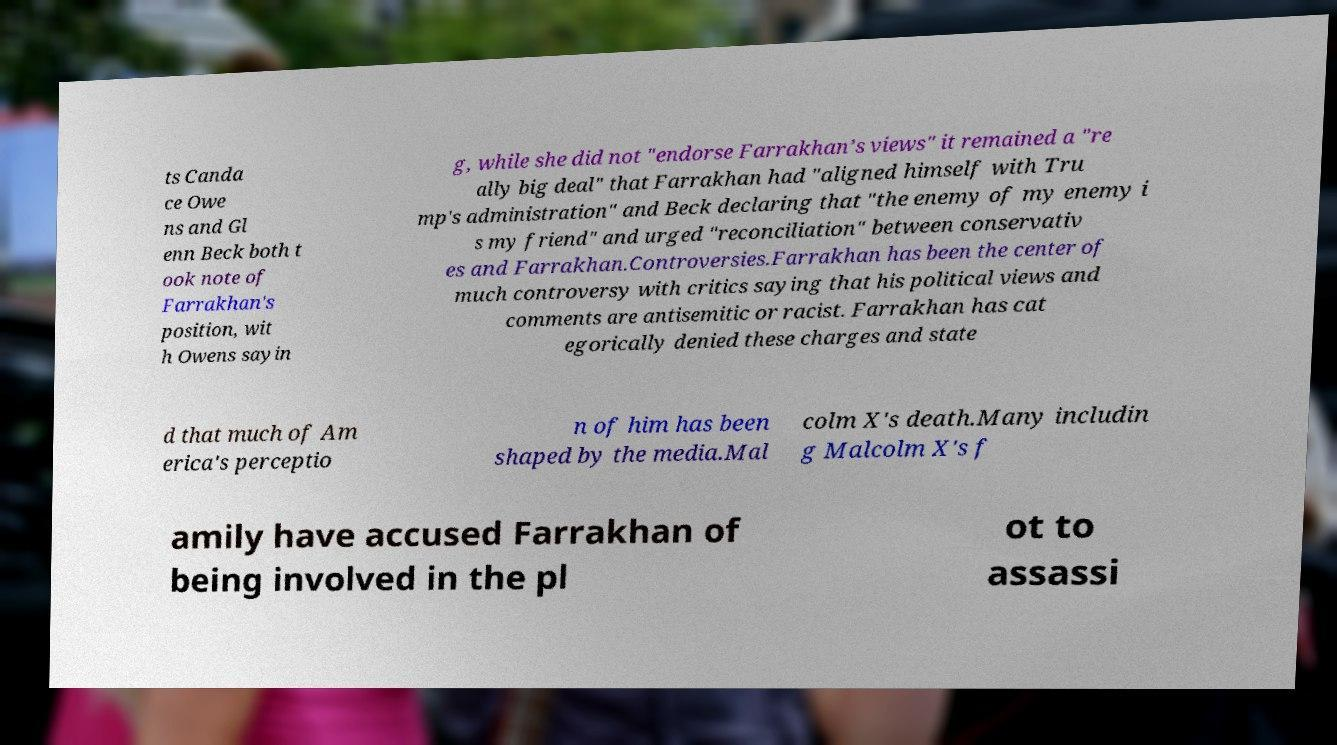Could you extract and type out the text from this image? ts Canda ce Owe ns and Gl enn Beck both t ook note of Farrakhan's position, wit h Owens sayin g, while she did not "endorse Farrakhan’s views" it remained a "re ally big deal" that Farrakhan had "aligned himself with Tru mp's administration" and Beck declaring that "the enemy of my enemy i s my friend" and urged "reconciliation" between conservativ es and Farrakhan.Controversies.Farrakhan has been the center of much controversy with critics saying that his political views and comments are antisemitic or racist. Farrakhan has cat egorically denied these charges and state d that much of Am erica's perceptio n of him has been shaped by the media.Mal colm X's death.Many includin g Malcolm X's f amily have accused Farrakhan of being involved in the pl ot to assassi 